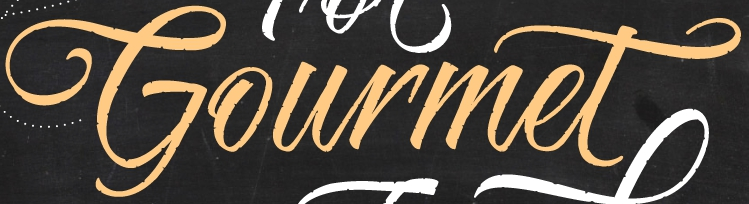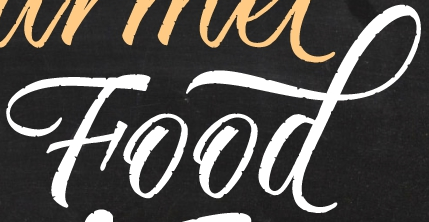What text appears in these images from left to right, separated by a semicolon? Gourmet; Food 